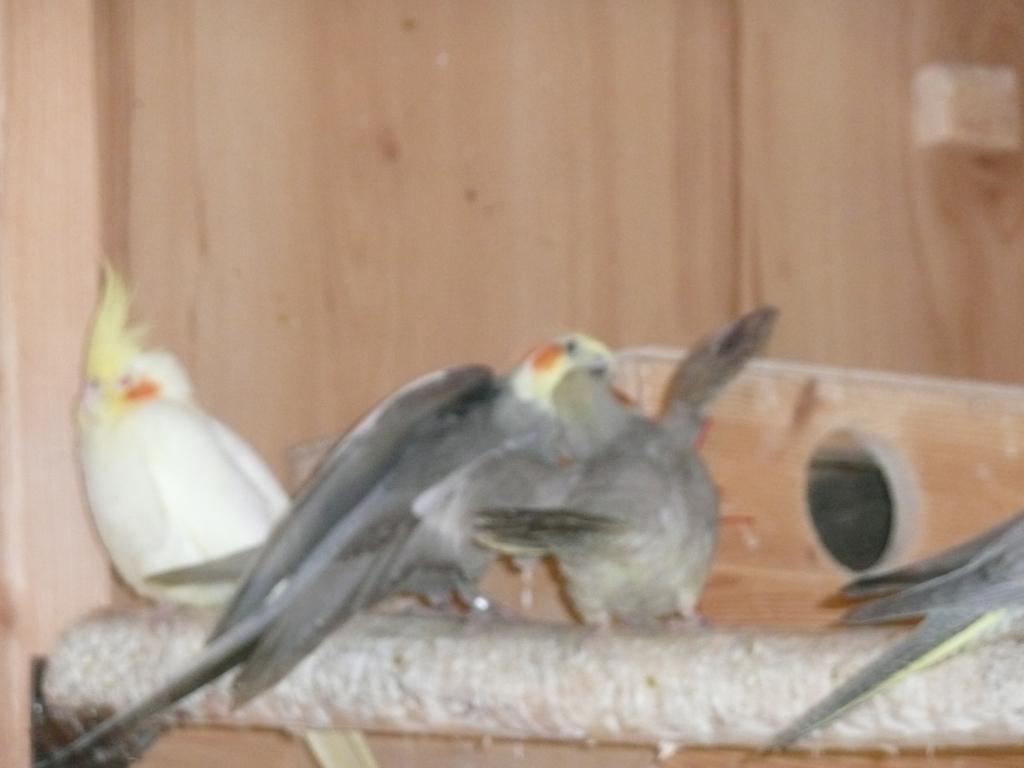In one or two sentences, can you explain what this image depicts? In this image there are some birds are there in middle of this image. The left side bird is in white color and there is a wall in the background and there is some object placed at bottom of this image. 